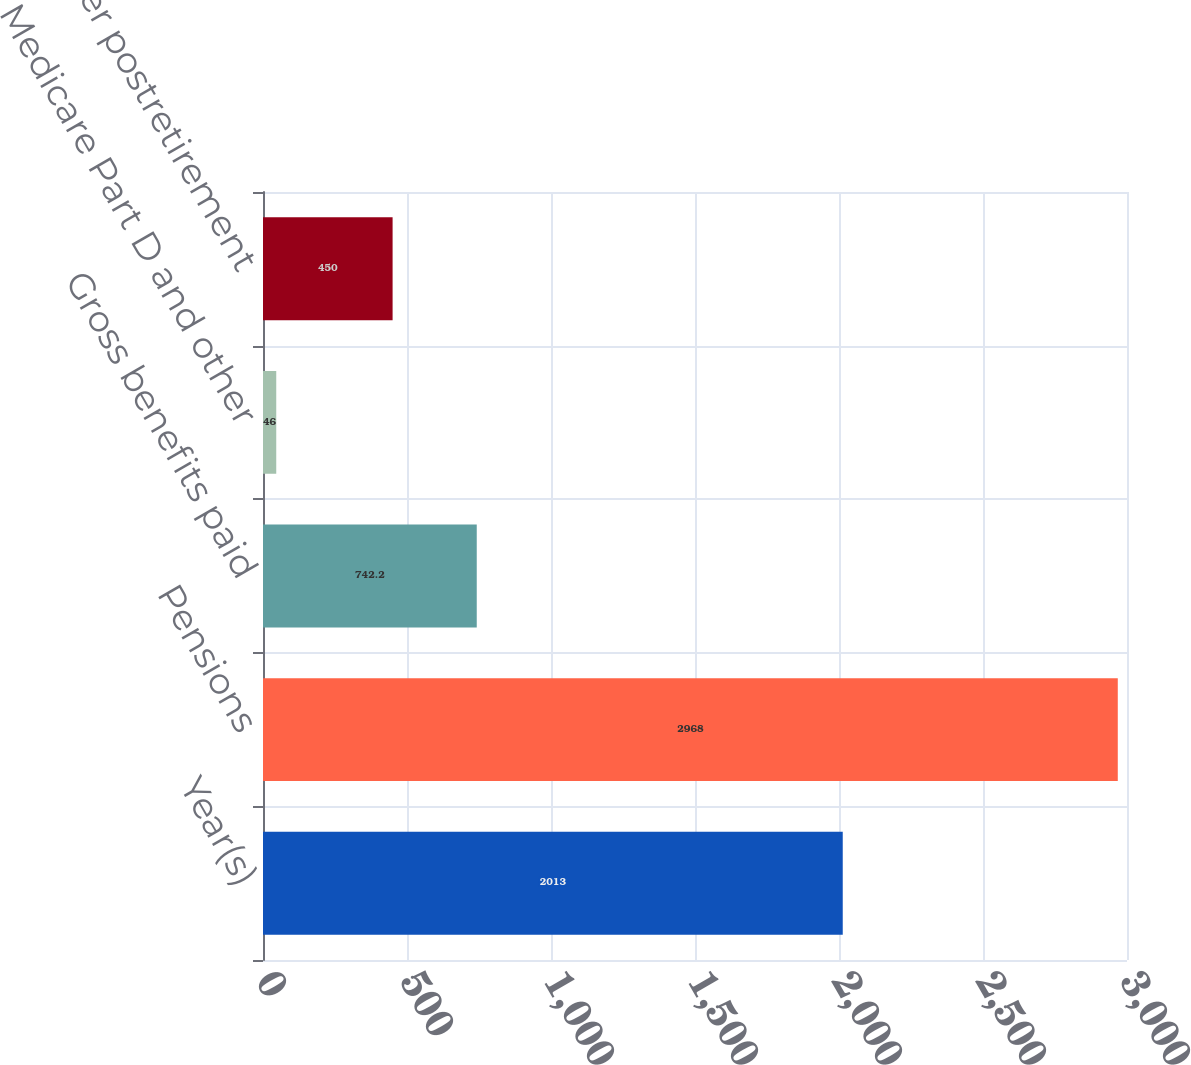<chart> <loc_0><loc_0><loc_500><loc_500><bar_chart><fcel>Year(s)<fcel>Pensions<fcel>Gross benefits paid<fcel>Medicare Part D and other<fcel>Net other postretirement<nl><fcel>2013<fcel>2968<fcel>742.2<fcel>46<fcel>450<nl></chart> 